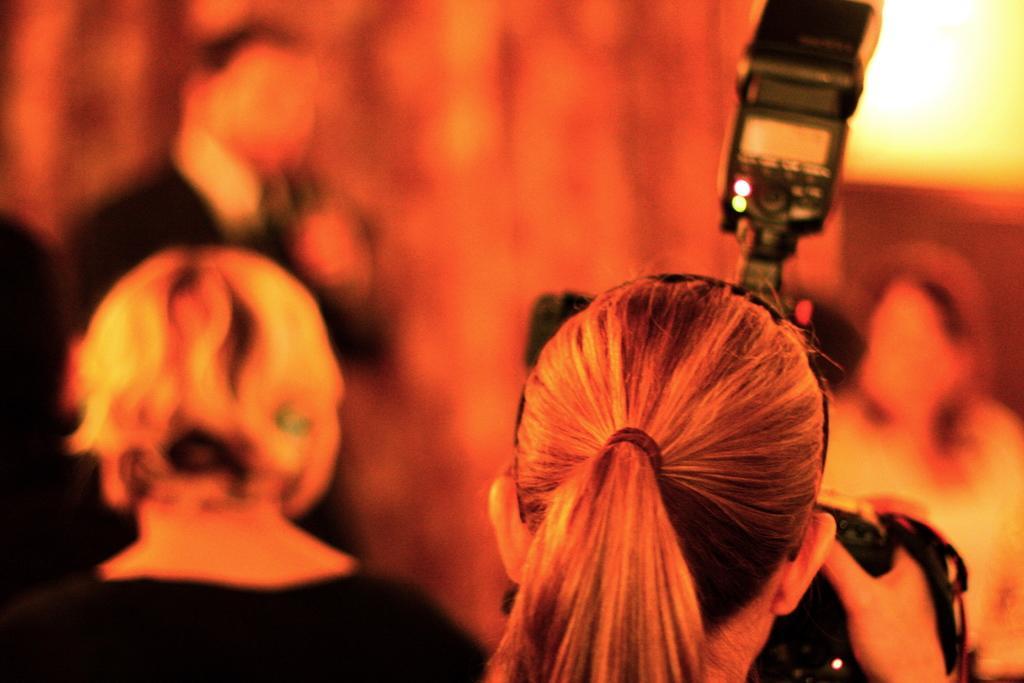Describe this image in one or two sentences. In the image few people are standing and she is holding a camera. Background of the image is blur. 